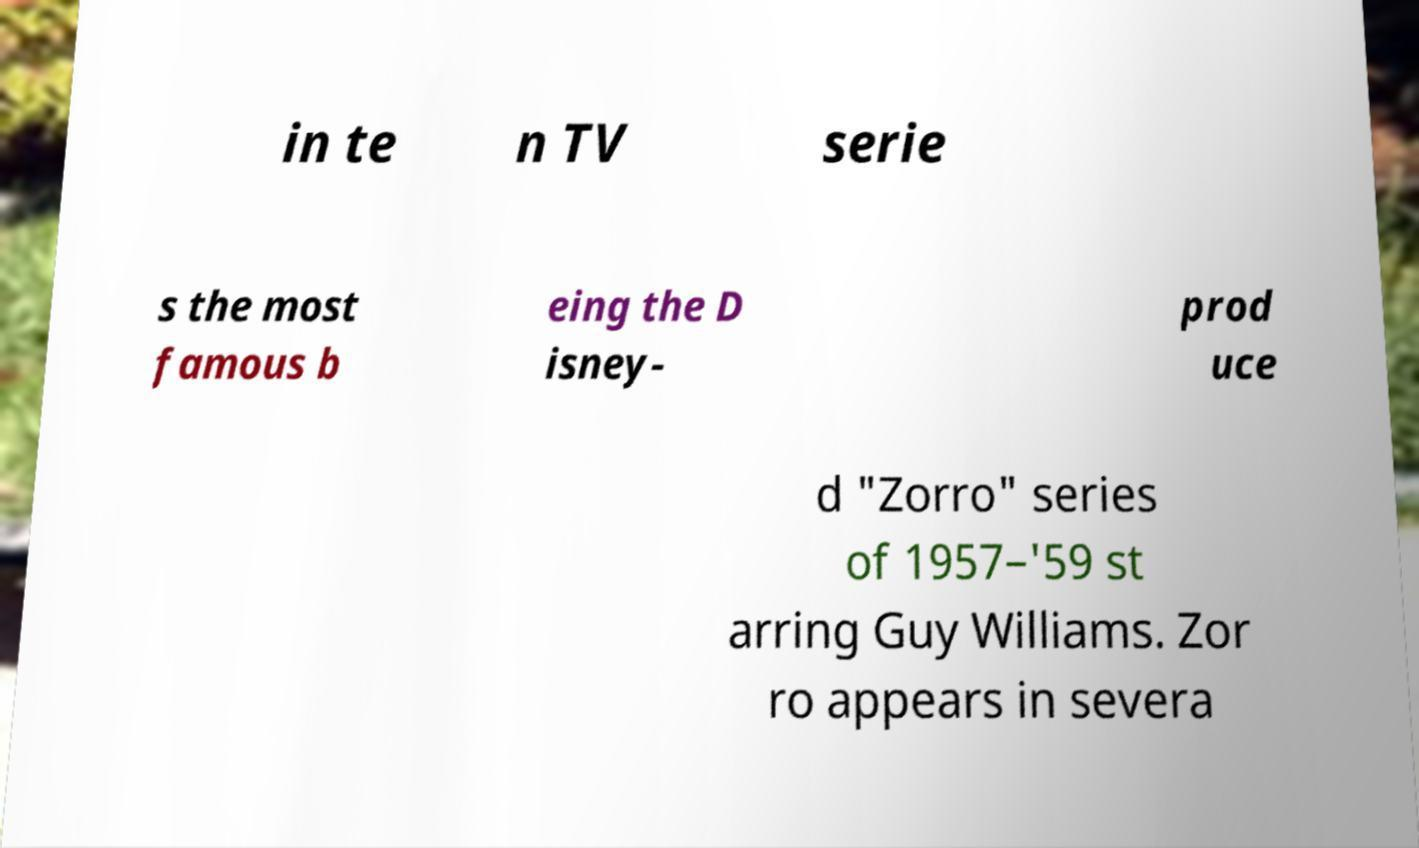For documentation purposes, I need the text within this image transcribed. Could you provide that? in te n TV serie s the most famous b eing the D isney- prod uce d "Zorro" series of 1957–'59 st arring Guy Williams. Zor ro appears in severa 